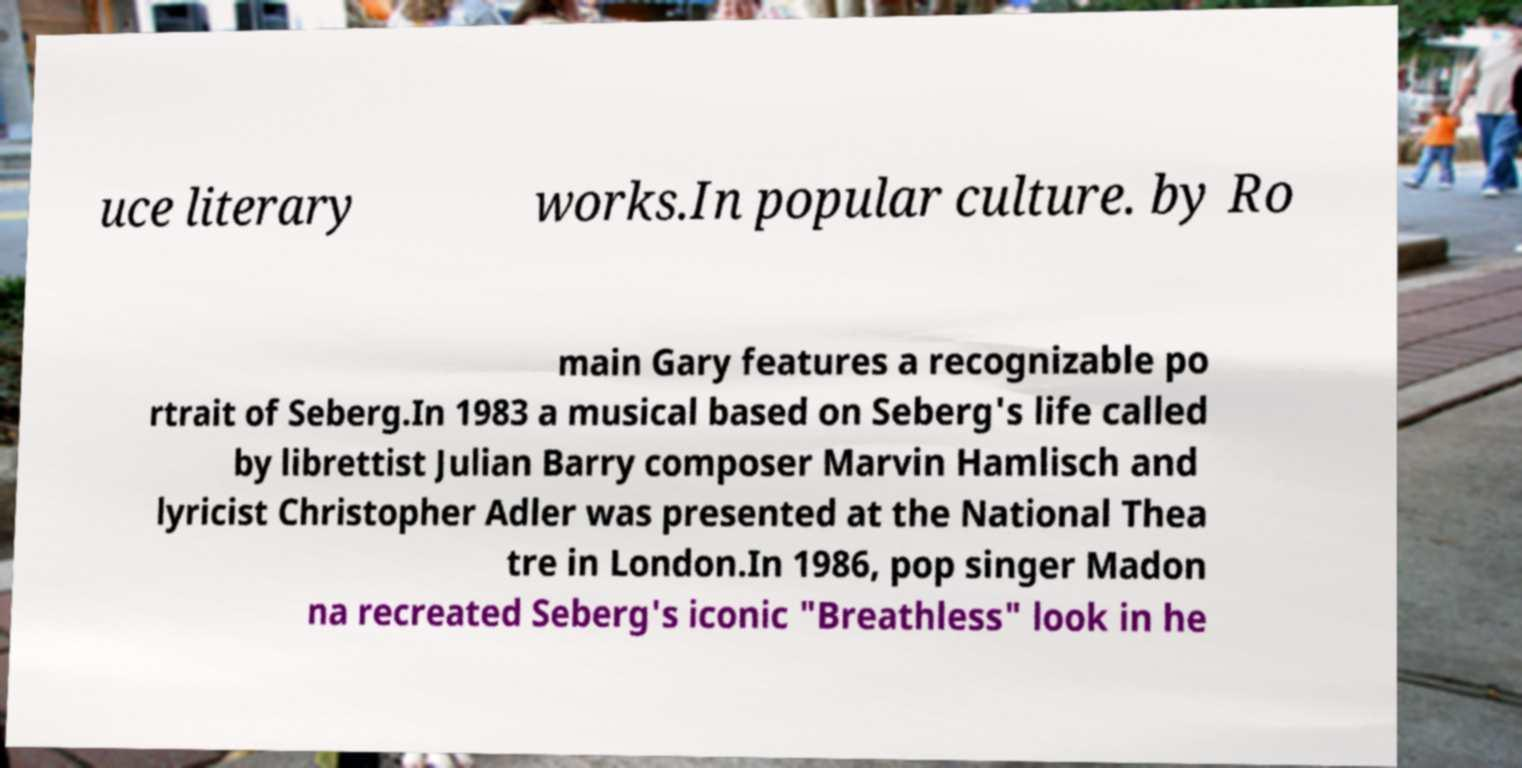Could you extract and type out the text from this image? uce literary works.In popular culture. by Ro main Gary features a recognizable po rtrait of Seberg.In 1983 a musical based on Seberg's life called by librettist Julian Barry composer Marvin Hamlisch and lyricist Christopher Adler was presented at the National Thea tre in London.In 1986, pop singer Madon na recreated Seberg's iconic "Breathless" look in he 